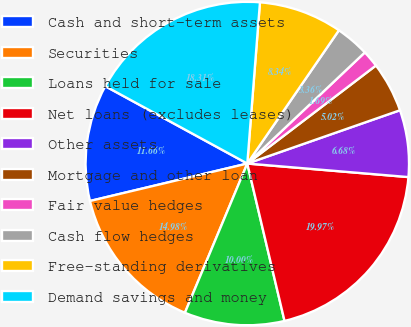Convert chart. <chart><loc_0><loc_0><loc_500><loc_500><pie_chart><fcel>Cash and short-term assets<fcel>Securities<fcel>Loans held for sale<fcel>Net loans (excludes leases)<fcel>Other assets<fcel>Mortgage and other loan<fcel>Fair value hedges<fcel>Cash flow hedges<fcel>Free-standing derivatives<fcel>Demand savings and money<nl><fcel>11.66%<fcel>14.98%<fcel>10.0%<fcel>19.97%<fcel>6.68%<fcel>5.02%<fcel>1.69%<fcel>3.36%<fcel>8.34%<fcel>18.31%<nl></chart> 